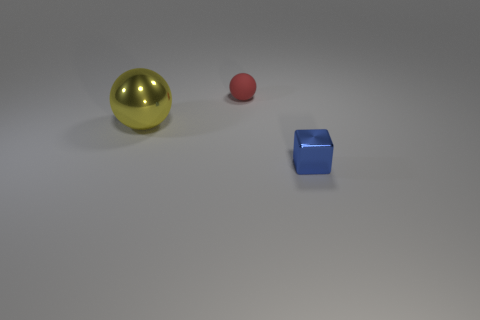Add 2 cyan metal balls. How many objects exist? 5 Subtract all cubes. How many objects are left? 2 Subtract all yellow things. Subtract all cubes. How many objects are left? 1 Add 2 tiny objects. How many tiny objects are left? 4 Add 1 big green cubes. How many big green cubes exist? 1 Subtract 0 green cubes. How many objects are left? 3 